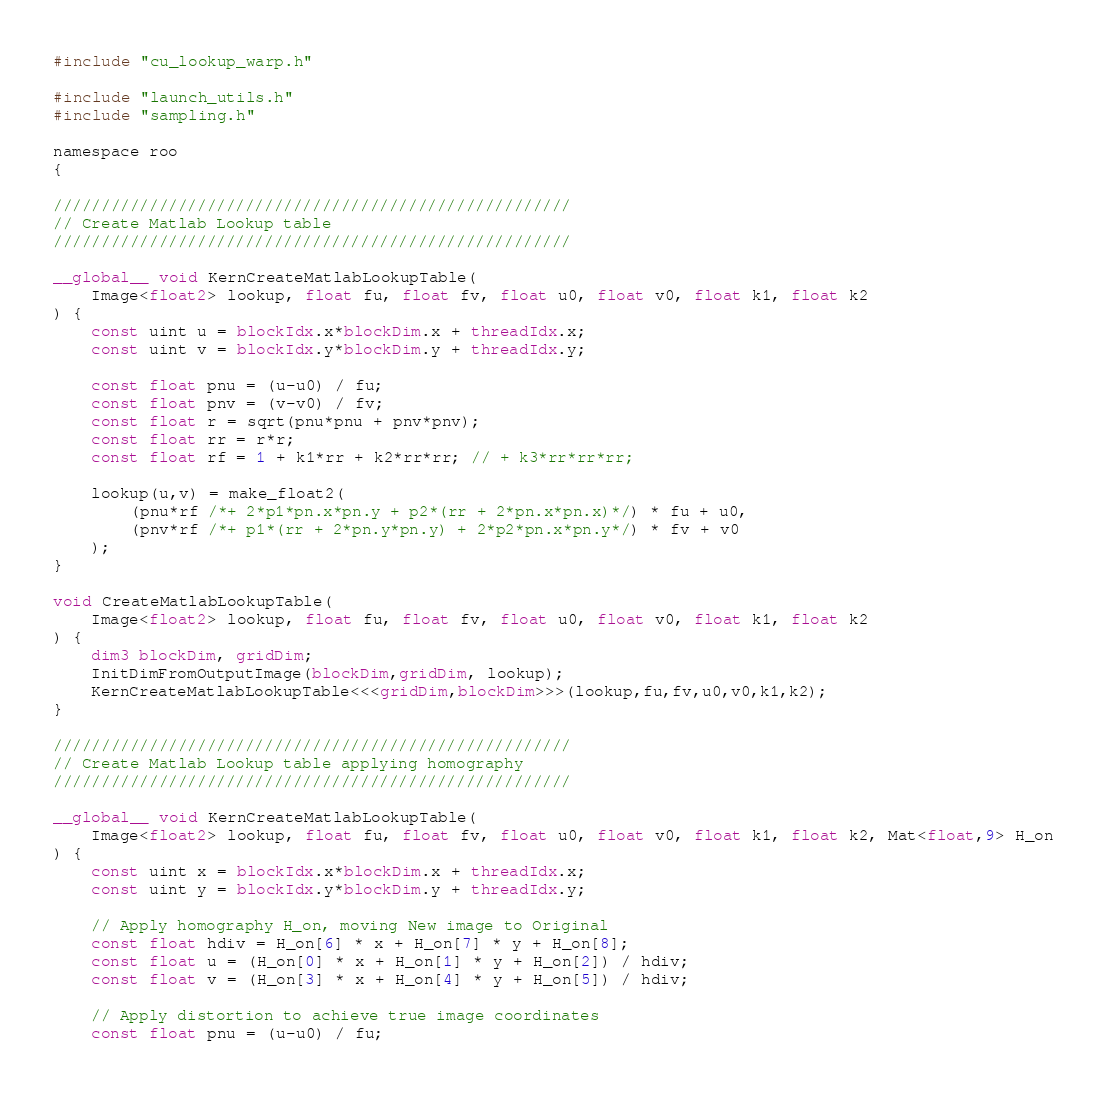Convert code to text. <code><loc_0><loc_0><loc_500><loc_500><_Cuda_>#include "cu_lookup_warp.h"

#include "launch_utils.h"
#include "sampling.h"

namespace roo
{

//////////////////////////////////////////////////////
// Create Matlab Lookup table
//////////////////////////////////////////////////////

__global__ void KernCreateMatlabLookupTable(
    Image<float2> lookup, float fu, float fv, float u0, float v0, float k1, float k2
) {
    const uint u = blockIdx.x*blockDim.x + threadIdx.x;
    const uint v = blockIdx.y*blockDim.y + threadIdx.y;

    const float pnu = (u-u0) / fu;
    const float pnv = (v-v0) / fv;
    const float r = sqrt(pnu*pnu + pnv*pnv);
    const float rr = r*r;
    const float rf = 1 + k1*rr + k2*rr*rr; // + k3*rr*rr*rr;

    lookup(u,v) = make_float2(
        (pnu*rf /*+ 2*p1*pn.x*pn.y + p2*(rr + 2*pn.x*pn.x)*/) * fu + u0,
        (pnv*rf /*+ p1*(rr + 2*pn.y*pn.y) + 2*p2*pn.x*pn.y*/) * fv + v0
    );
}

void CreateMatlabLookupTable(
    Image<float2> lookup, float fu, float fv, float u0, float v0, float k1, float k2
) {
    dim3 blockDim, gridDim;
    InitDimFromOutputImage(blockDim,gridDim, lookup);
    KernCreateMatlabLookupTable<<<gridDim,blockDim>>>(lookup,fu,fv,u0,v0,k1,k2);
}

//////////////////////////////////////////////////////
// Create Matlab Lookup table applying homography
//////////////////////////////////////////////////////

__global__ void KernCreateMatlabLookupTable(
    Image<float2> lookup, float fu, float fv, float u0, float v0, float k1, float k2, Mat<float,9> H_on
) {
    const uint x = blockIdx.x*blockDim.x + threadIdx.x;
    const uint y = blockIdx.y*blockDim.y + threadIdx.y;

    // Apply homography H_on, moving New image to Original
    const float hdiv = H_on[6] * x + H_on[7] * y + H_on[8];
    const float u = (H_on[0] * x + H_on[1] * y + H_on[2]) / hdiv;
    const float v = (H_on[3] * x + H_on[4] * y + H_on[5]) / hdiv;

    // Apply distortion to achieve true image coordinates
    const float pnu = (u-u0) / fu;</code> 